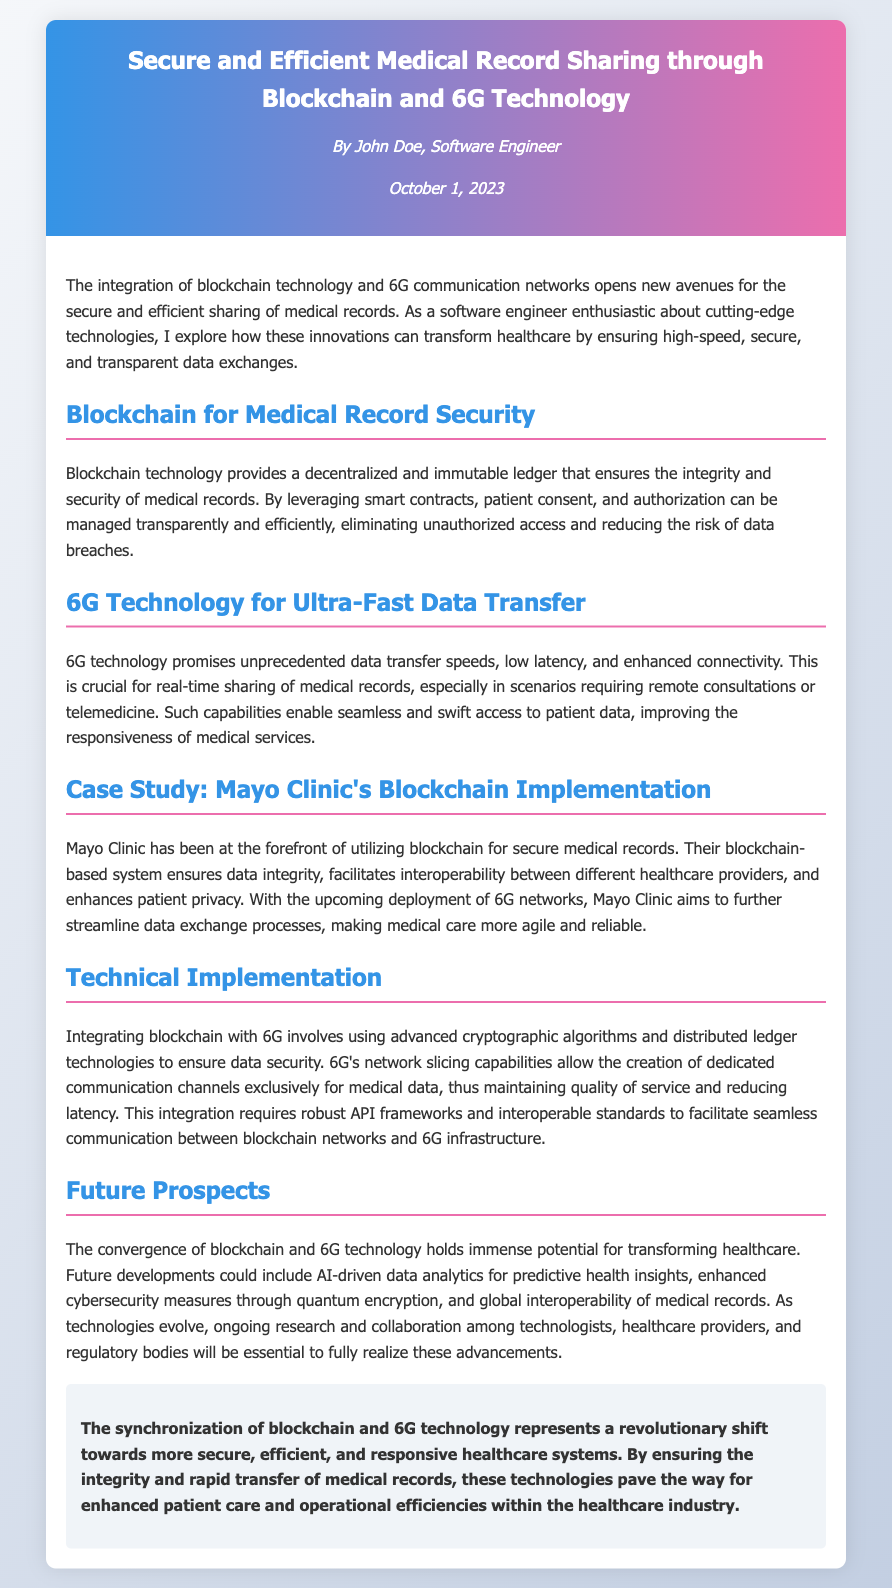What is the title of the document? The title of the document is mentioned in the header and summarizes its main topic.
Answer: Secure and Efficient Medical Record Sharing through Blockchain and 6G Technology Who is the author of the document? The author is specified in the author-date section of the header.
Answer: John Doe What technology is mentioned as promising unprecedented data transfer speeds? The document describes this technology in the context of medical records sharing.
Answer: 6G Technology What healthcare institution is used as a case study in the document? The case study section identifies the institution involved in blockchain implementation.
Answer: Mayo Clinic What benefit does blockchain provide for medical records? The document explains this advantage in relation to security and integrity.
Answer: Decentralized and immutable ledger What capability does 6G provide that is crucial for real-time sharing? This capability is highlighted in relation to telemedicine and remote consultations.
Answer: Low latency What should be ensured for the integration of blockchain with 6G? The section on technical implementation discusses essential factors for successful integration.
Answer: Data security What does the future prospect section suggest for predictive health insights? The document implies advancements that could arise from the convergence of the technologies.
Answer: AI-driven data analytics 